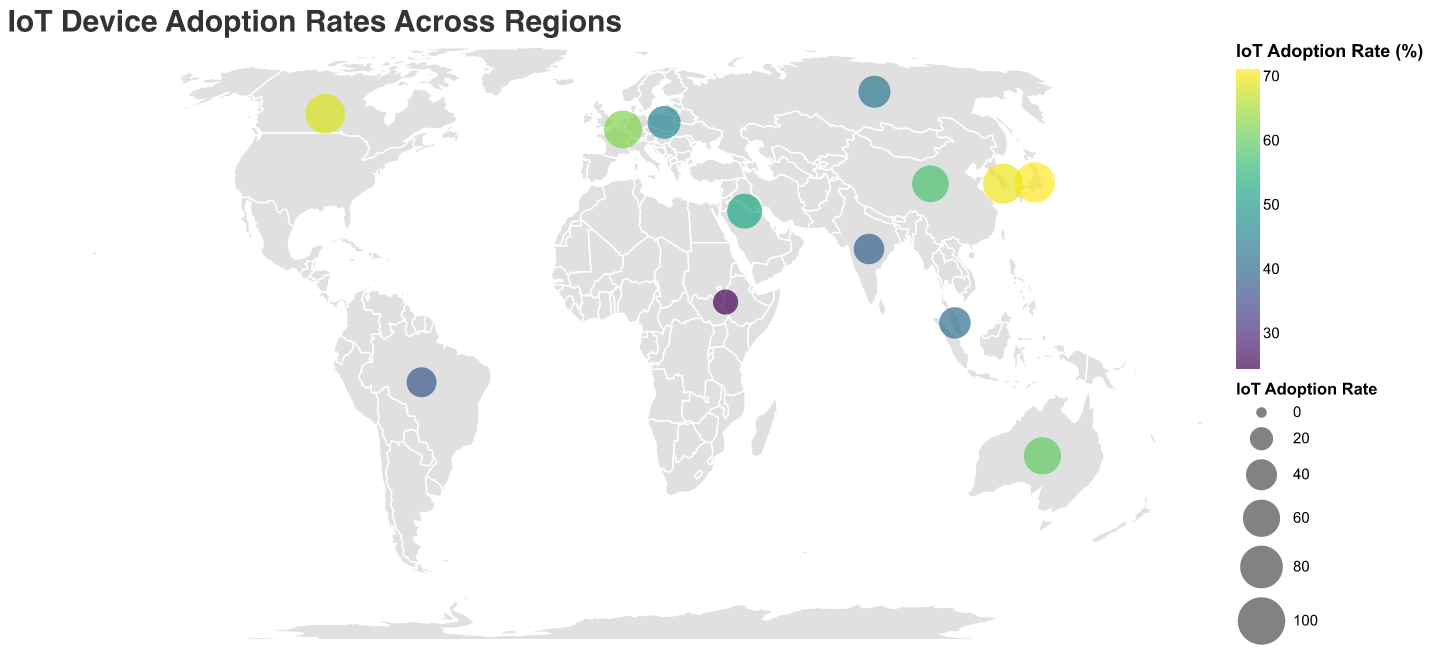What is the region with the highest IoT adoption rate? By looking at the plot, you can identify the region with the largest circle and the highest value on the color scale. The title of the region will be visible when you hover over the circle in the visualization.
Answer: Japan What is the IoT adoption rate for Africa? The visualization labels Africa’s IoT adoption rate with a specific data point. By locating the circle on the map for Africa, you can read the value indicated by its color and size.
Answer: 24.5% How much higher is the IoT adoption rate in South Korea compared to Eastern Europe? First, find South Korea's IoT adoption rate, which is 69.8%. Then, find Eastern Europe's IoT adoption rate, which is 45.7%. Subtract the latter from the former to find the difference: 69.8% - 45.7% = 24.1%.
Answer: 24.1% Which two regions have the closest IoT adoption rates? Compare the IoT adoption rates visually or by reading the labels. Identify the two regions with the smallest difference.
Answer: Eastern Europe (45.7%) and Russia (43.2%) What is the average IoT adoption rate across all regions? Sum all the adoption rates and then divide by the number of regions (13). The sum is 68.5 + 62.3 + 45.7 + 57.9 + 71.2 + 69.8 + 41.3 + 38.6 + 52.1 + 36.9 + 24.5 + 59.7 + 43.2 = 671.7. Divide this by 13 to get the average: 671.7 / 13 ≈ 51.7%.
Answer: 51.7% Which region in Asia has the lowest IoT adoption rate? By identifying and comparing the IoT adoption rates for Asian regions (China, Japan, South Korea, Southeast Asia, and India) from the plot. The region with the smallest circle and a low color scale value is the one with the lowest adoption rate.
Answer: India In which region is the IoT adoption rate less than 50%? Scan through the plot to find circles whose size and color indicate IoT adoption rates below 50%. Read off the region names from the labels.
Answer: Eastern Europe, Southeast Asia, India, Latin America, Africa, Russia What is the total IoT adoption rate for North America and Western Europe combined? Find the rate for North America (68.5%) and Western Europe (62.3%) on the plot, then add them together: 68.5% + 62.3% = 130.8%.
Answer: 130.8% Which has a higher IoT adoption rate: Australia or China? Locate the circles representing Australia and China, then compare the sizes and color scales to determine which is higher.
Answer: Australia How many regions have an IoT adoption rate above 60%? Identify all the regions with circles that indicate adoption rates over 60% by looking at the size and color. Count these regions.
Answer: 5 regions 